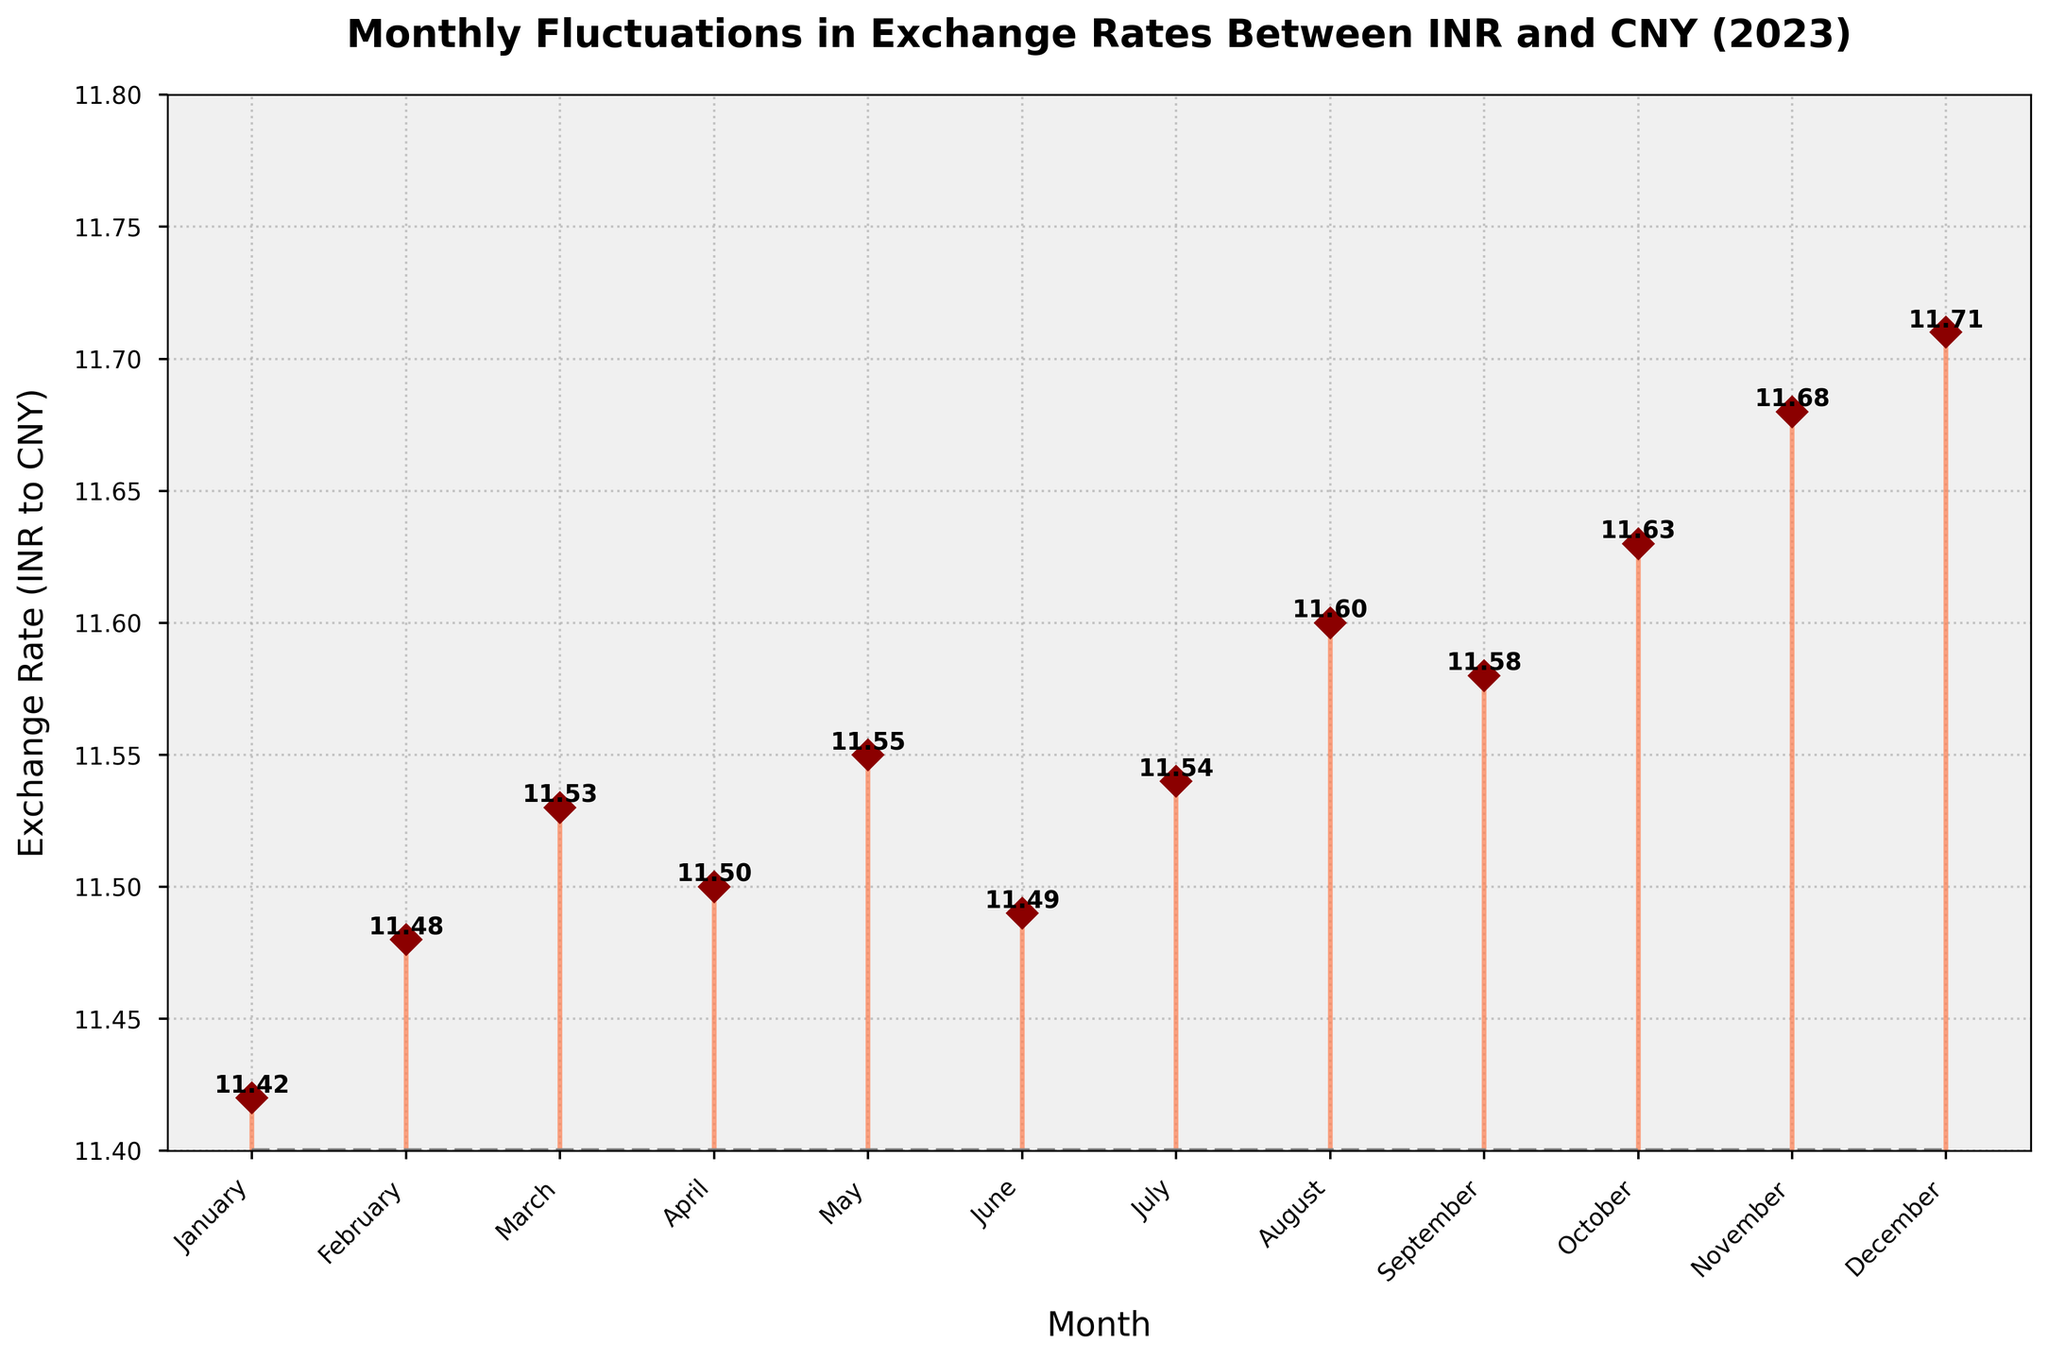What is the title of the figure? The title of the figure is displayed at the top of the plot. It reads "Monthly Fluctuations in Exchange Rates Between INR and CNY (2023)"
Answer: Monthly Fluctuations in Exchange Rates Between INR and CNY (2023) What is the exchange rate in March 2023? Locate March on the x-axis and refer to the marker on the y-axis. The value label next to the marker for March shows 11.53
Answer: 11.53 Which month has the highest exchange rate? Observe the y-axis values and identify the month with the highest value label. December shows the highest exchange rate of 11.71
Answer: December What is the difference between the exchange rates in July and August 2023? The exchange rate in July is 11.54 and in August is 11.60. Subtract the value for July from that for August (11.60 - 11.54) = 0.06
Answer: 0.06 How many months have an exchange rate greater than 11.55? Check the y-axis values of all the months and count how many exceed 11.55. These months are August, September, October, November, and December (5 months)
Answer: 5 Are there any months where the exchange rate decreased compared to the previous month? Compare the exchange rates month by month. From March to April (11.53 to 11.50) and from May to June (11.55 to 11.49), the rate decreased
Answer: March to April, May to June What is the average exchange rate for the year 2023? Sum all the monthly exchange rates and divide by 12. The calculation is (11.42 + 11.48 + 11.53 + 11.50 + 11.55 + 11.49 + 11.54 + 11.60 + 11.58 + 11.63 + 11.68 + 11.71) / 12 = 11.56
Answer: 11.56 Which month shows the largest increase in exchange rate compared to the previous month? Calculate the month-to-month differences and find the largest positive change. The largest increase is from July (11.54) to August (11.60), with a difference of 0.06
Answer: July to August What is the range of the exchange rates for 2023? The range is the difference between the highest and lowest exchange rates. The highest is 11.71 (December) and the lowest is 11.42 (January). Range = 11.71 - 11.42 = 0.29
Answer: 0.29 